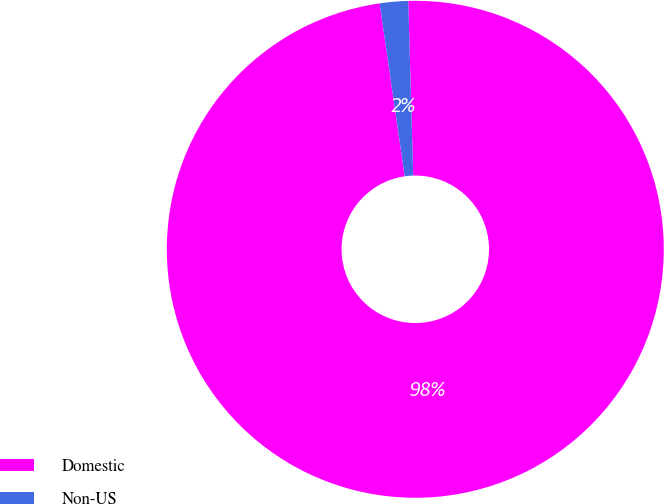Convert chart to OTSL. <chart><loc_0><loc_0><loc_500><loc_500><pie_chart><fcel>Domestic<fcel>Non-US<nl><fcel>98.16%<fcel>1.84%<nl></chart> 